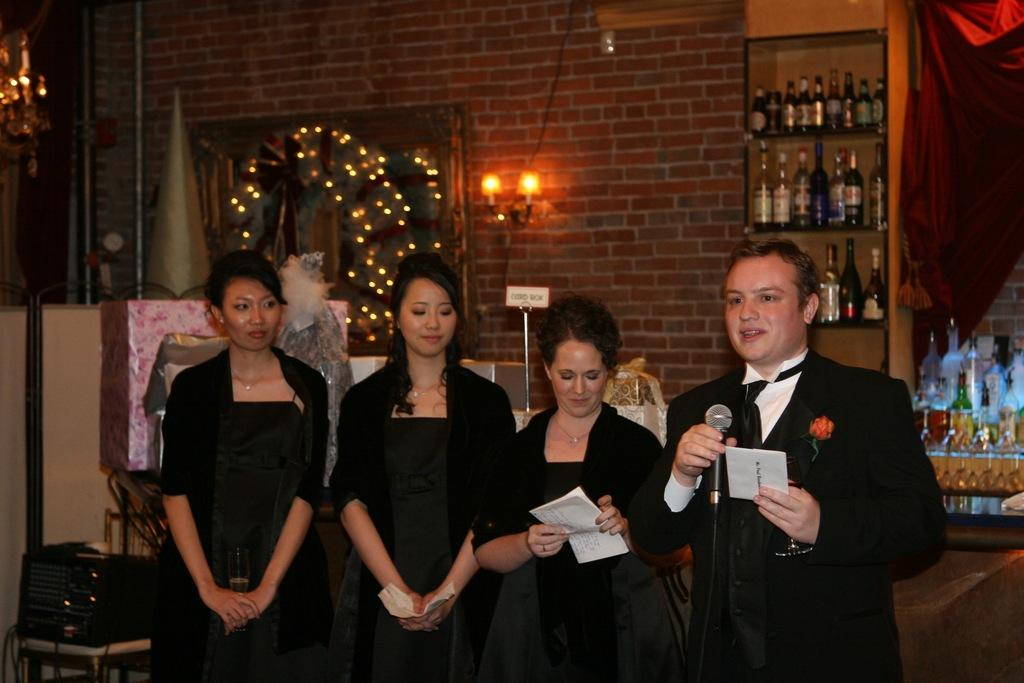What are the persons in the image doing? The persons in the image are holding objects. What can be seen in the background of the image? There are lights, bottles, a wall, and other objects in the background of the image. What type of form is being filled out by the persons in the image? There is no form present in the image; the persons are holding objects. What pen is being used by the persons to fill out the form in the image? There is no pen or form present in the image. 